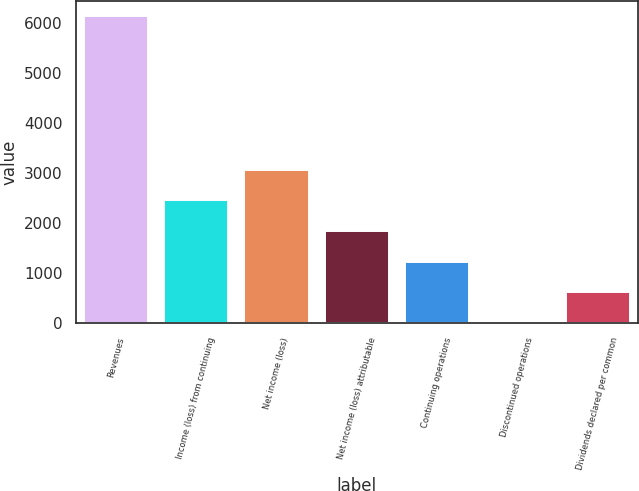Convert chart. <chart><loc_0><loc_0><loc_500><loc_500><bar_chart><fcel>Revenues<fcel>Income (loss) from continuing<fcel>Net income (loss)<fcel>Net income (loss) attributable<fcel>Continuing operations<fcel>Discontinued operations<fcel>Dividends declared per common<nl><fcel>6124<fcel>2449.63<fcel>3062.03<fcel>1837.23<fcel>1224.83<fcel>0.03<fcel>612.43<nl></chart> 